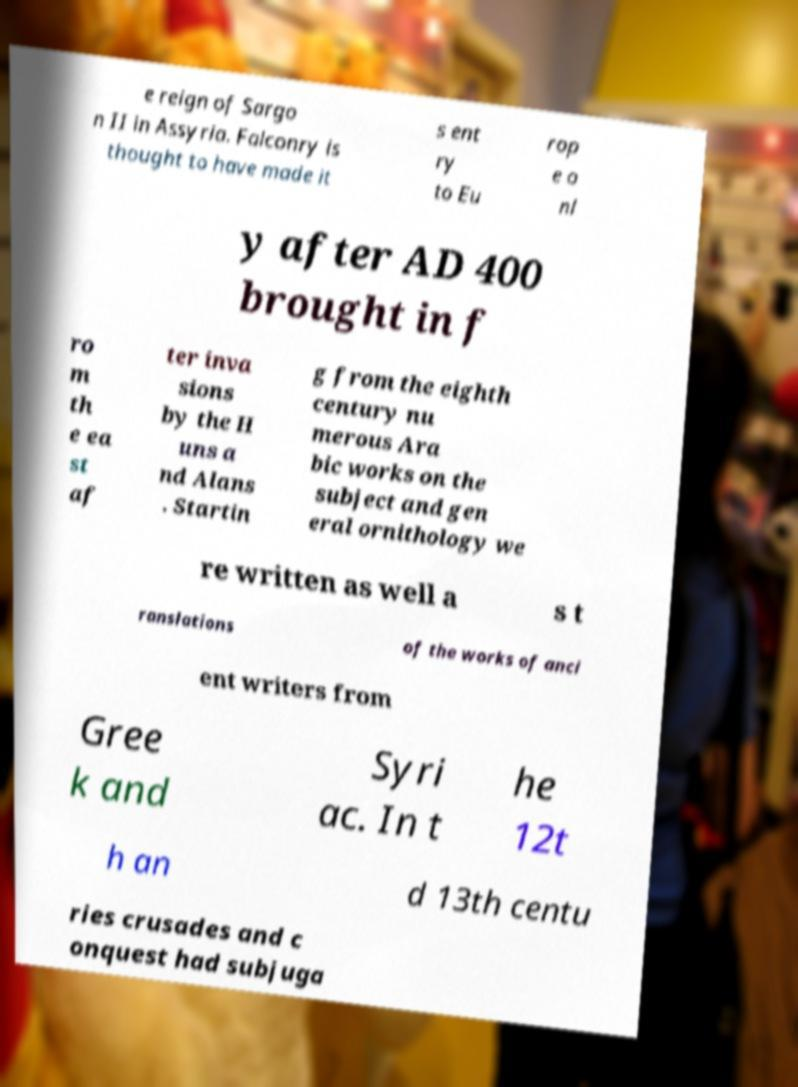Could you assist in decoding the text presented in this image and type it out clearly? e reign of Sargo n II in Assyria. Falconry is thought to have made it s ent ry to Eu rop e o nl y after AD 400 brought in f ro m th e ea st af ter inva sions by the H uns a nd Alans . Startin g from the eighth century nu merous Ara bic works on the subject and gen eral ornithology we re written as well a s t ranslations of the works of anci ent writers from Gree k and Syri ac. In t he 12t h an d 13th centu ries crusades and c onquest had subjuga 